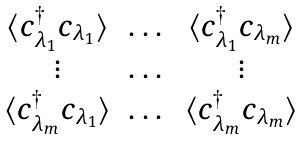Convert formula to latex. <formula><loc_0><loc_0><loc_500><loc_500>\begin{matrix} \langle c _ { \lambda _ { 1 } } ^ { \dagger } c _ { \lambda _ { 1 } } \rangle & \dots & \langle c _ { \lambda _ { 1 } } ^ { \dagger } c _ { \lambda _ { m } } \rangle \\ \vdots & \dots & \vdots \\ \langle c _ { \lambda _ { m } } ^ { \dagger } c _ { \lambda _ { 1 } } \rangle & \dots & \langle c _ { \lambda _ { m } } ^ { \dagger } c _ { \lambda _ { m } } \rangle \end{matrix}</formula> 